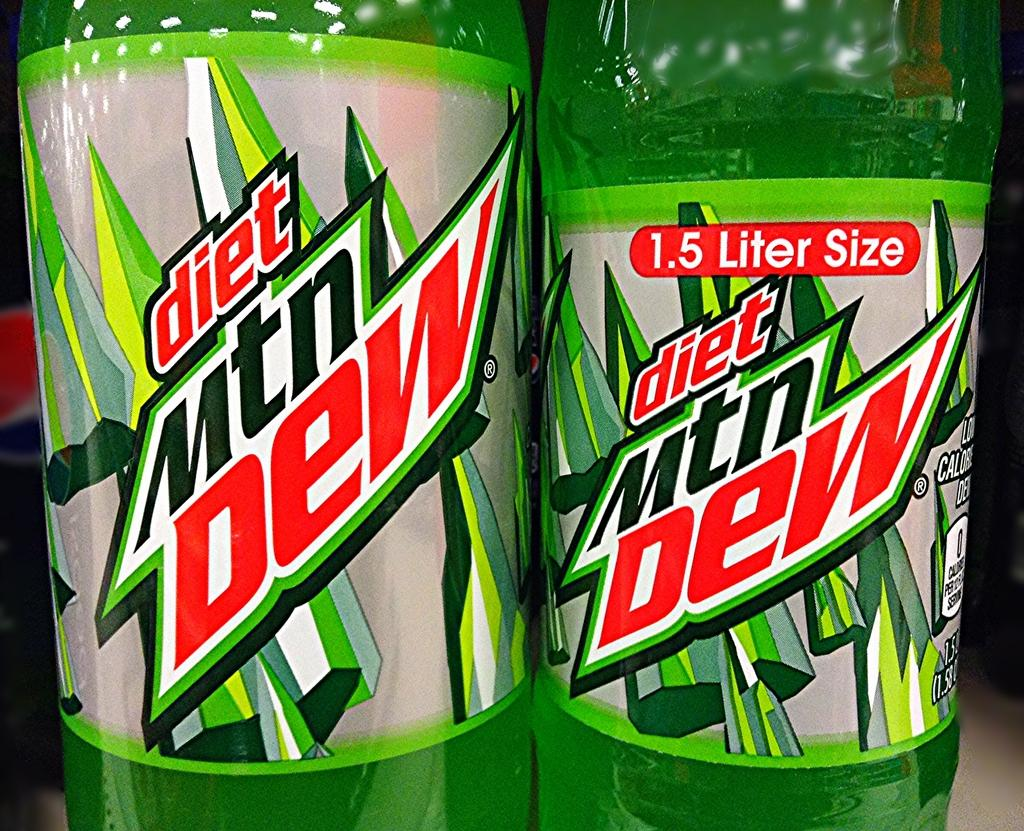Provide a one-sentence caption for the provided image. A diet Mtn Dew bottle is 1.5 Liters in size. 